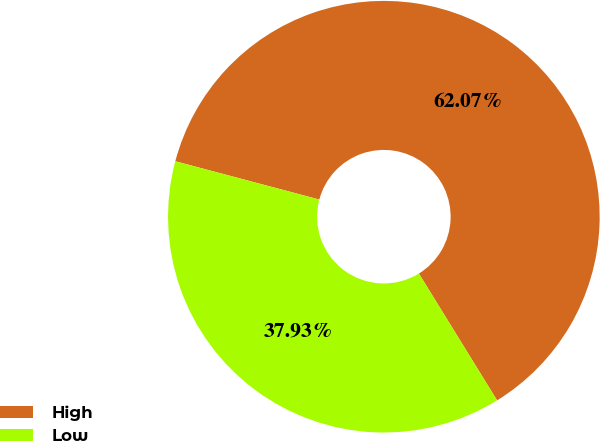Convert chart to OTSL. <chart><loc_0><loc_0><loc_500><loc_500><pie_chart><fcel>High<fcel>Low<nl><fcel>62.07%<fcel>37.93%<nl></chart> 